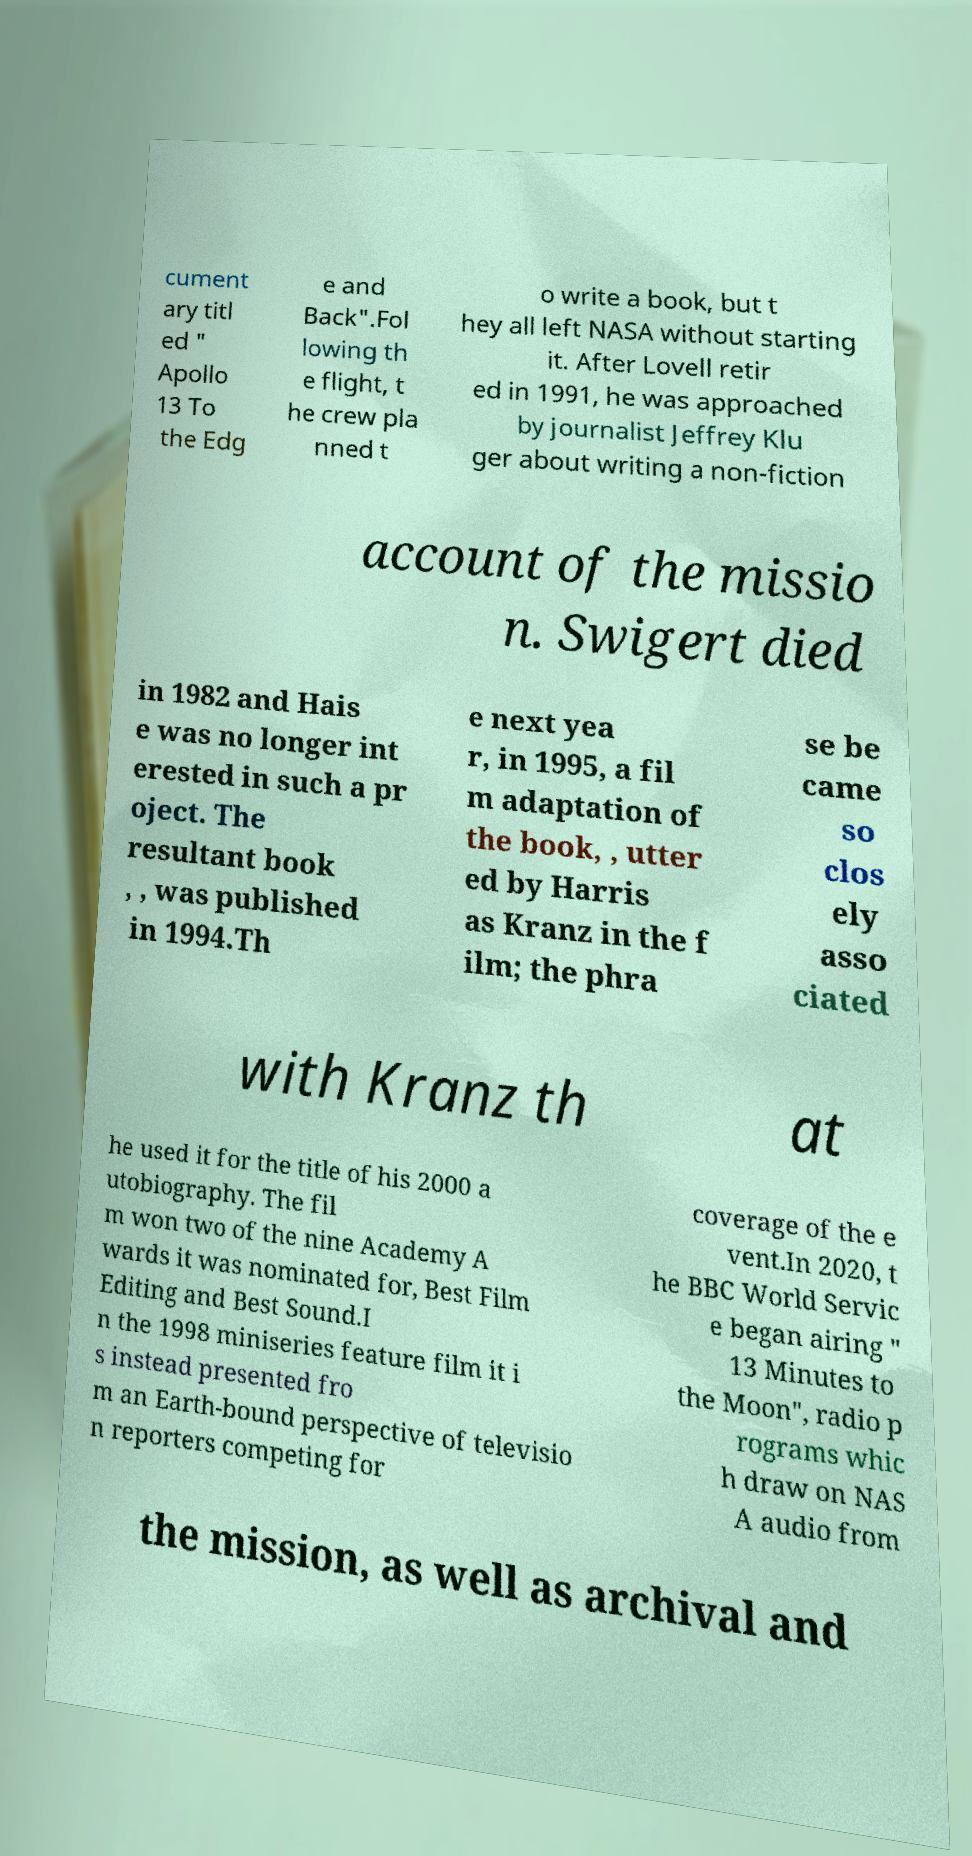Could you assist in decoding the text presented in this image and type it out clearly? cument ary titl ed " Apollo 13 To the Edg e and Back".Fol lowing th e flight, t he crew pla nned t o write a book, but t hey all left NASA without starting it. After Lovell retir ed in 1991, he was approached by journalist Jeffrey Klu ger about writing a non-fiction account of the missio n. Swigert died in 1982 and Hais e was no longer int erested in such a pr oject. The resultant book , , was published in 1994.Th e next yea r, in 1995, a fil m adaptation of the book, , utter ed by Harris as Kranz in the f ilm; the phra se be came so clos ely asso ciated with Kranz th at he used it for the title of his 2000 a utobiography. The fil m won two of the nine Academy A wards it was nominated for, Best Film Editing and Best Sound.I n the 1998 miniseries feature film it i s instead presented fro m an Earth-bound perspective of televisio n reporters competing for coverage of the e vent.In 2020, t he BBC World Servic e began airing " 13 Minutes to the Moon", radio p rograms whic h draw on NAS A audio from the mission, as well as archival and 